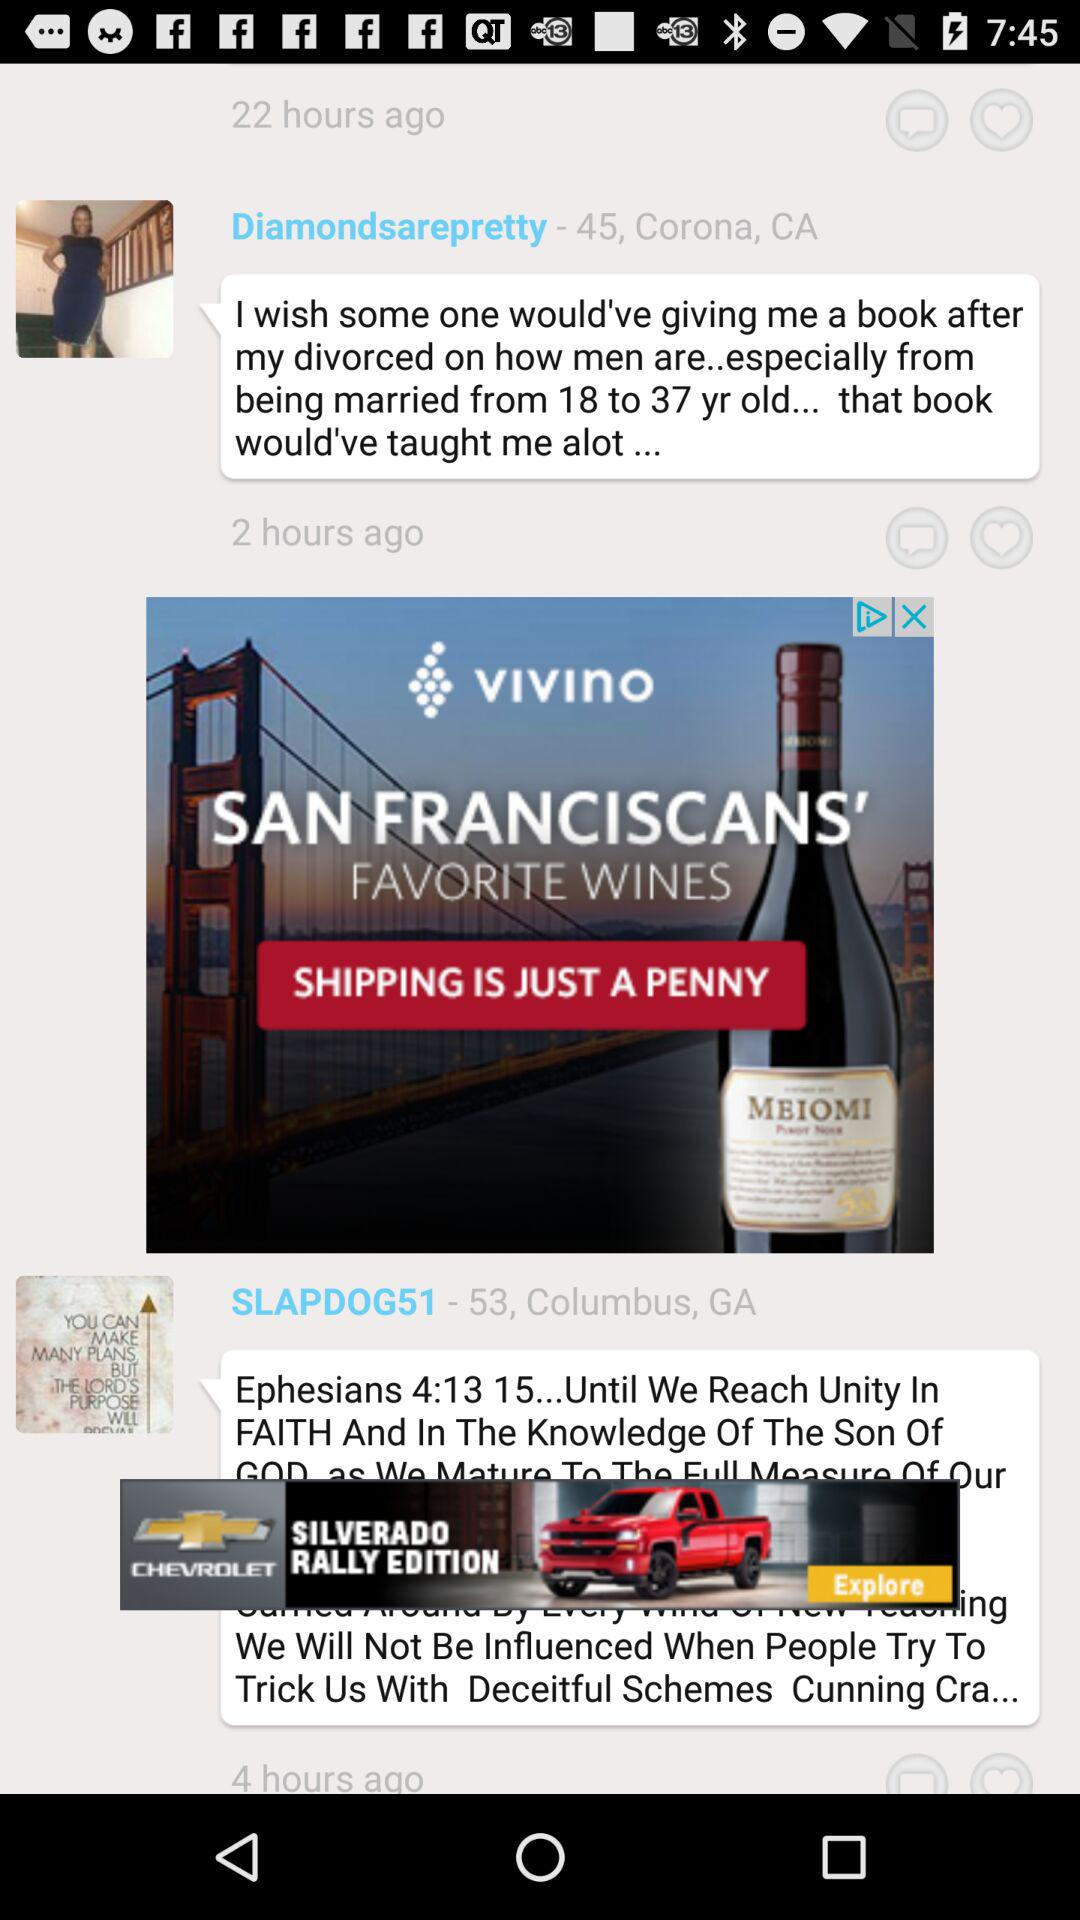How many years old is "SLAPDOG51"? "SLAPDOG51" is 53 years old. 